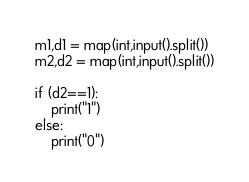<code> <loc_0><loc_0><loc_500><loc_500><_Python_>m1,d1 = map(int,input().split())
m2,d2 = map(int,input().split())

if (d2==1):
    print("1")
else:
    print("0")</code> 